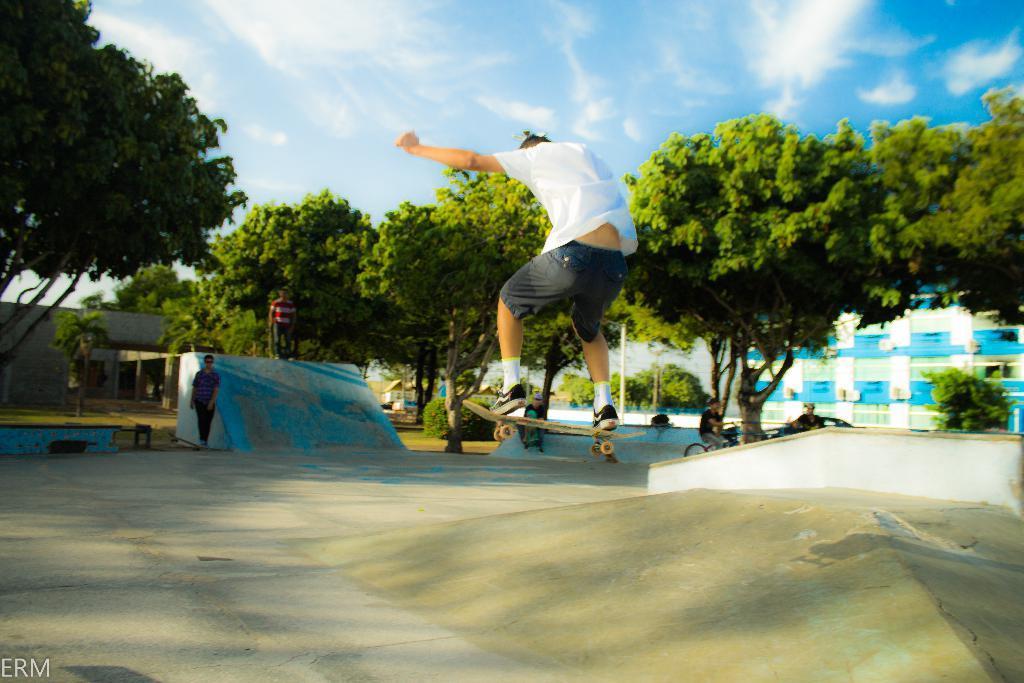Please provide a concise description of this image. In this image we can see few people, a person is on the skateboard, a person is sitting on bicycle and some of them are standing and in the background there are trees,buildings and sky. 